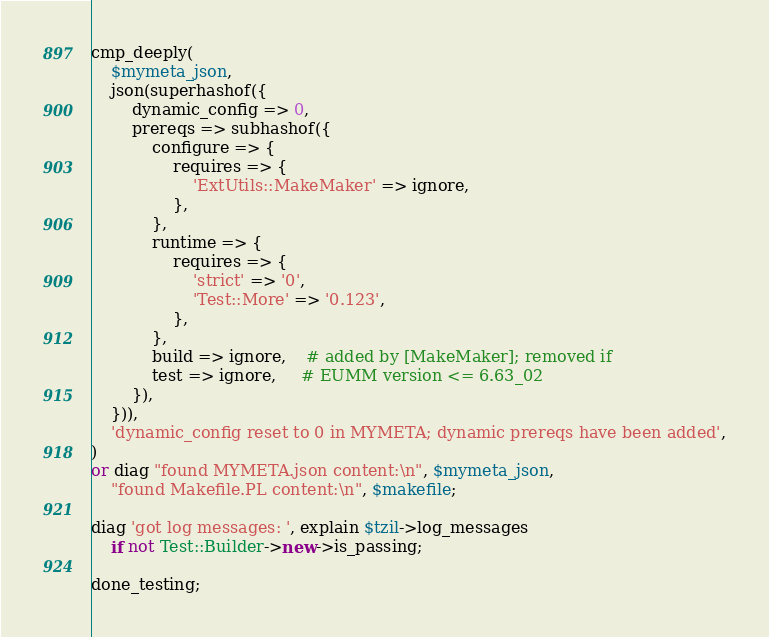Convert code to text. <code><loc_0><loc_0><loc_500><loc_500><_Perl_>cmp_deeply(
    $mymeta_json,
    json(superhashof({
        dynamic_config => 0,
        prereqs => subhashof({
            configure => {
                requires => {
                    'ExtUtils::MakeMaker' => ignore,
                },
            },
            runtime => {
                requires => {
                    'strict' => '0',
                    'Test::More' => '0.123',
                },
            },
            build => ignore,    # added by [MakeMaker]; removed if
            test => ignore,     # EUMM version <= 6.63_02
        }),
    })),
    'dynamic_config reset to 0 in MYMETA; dynamic prereqs have been added',
)
or diag "found MYMETA.json content:\n", $mymeta_json,
    "found Makefile.PL content:\n", $makefile;

diag 'got log messages: ', explain $tzil->log_messages
    if not Test::Builder->new->is_passing;

done_testing;
</code> 